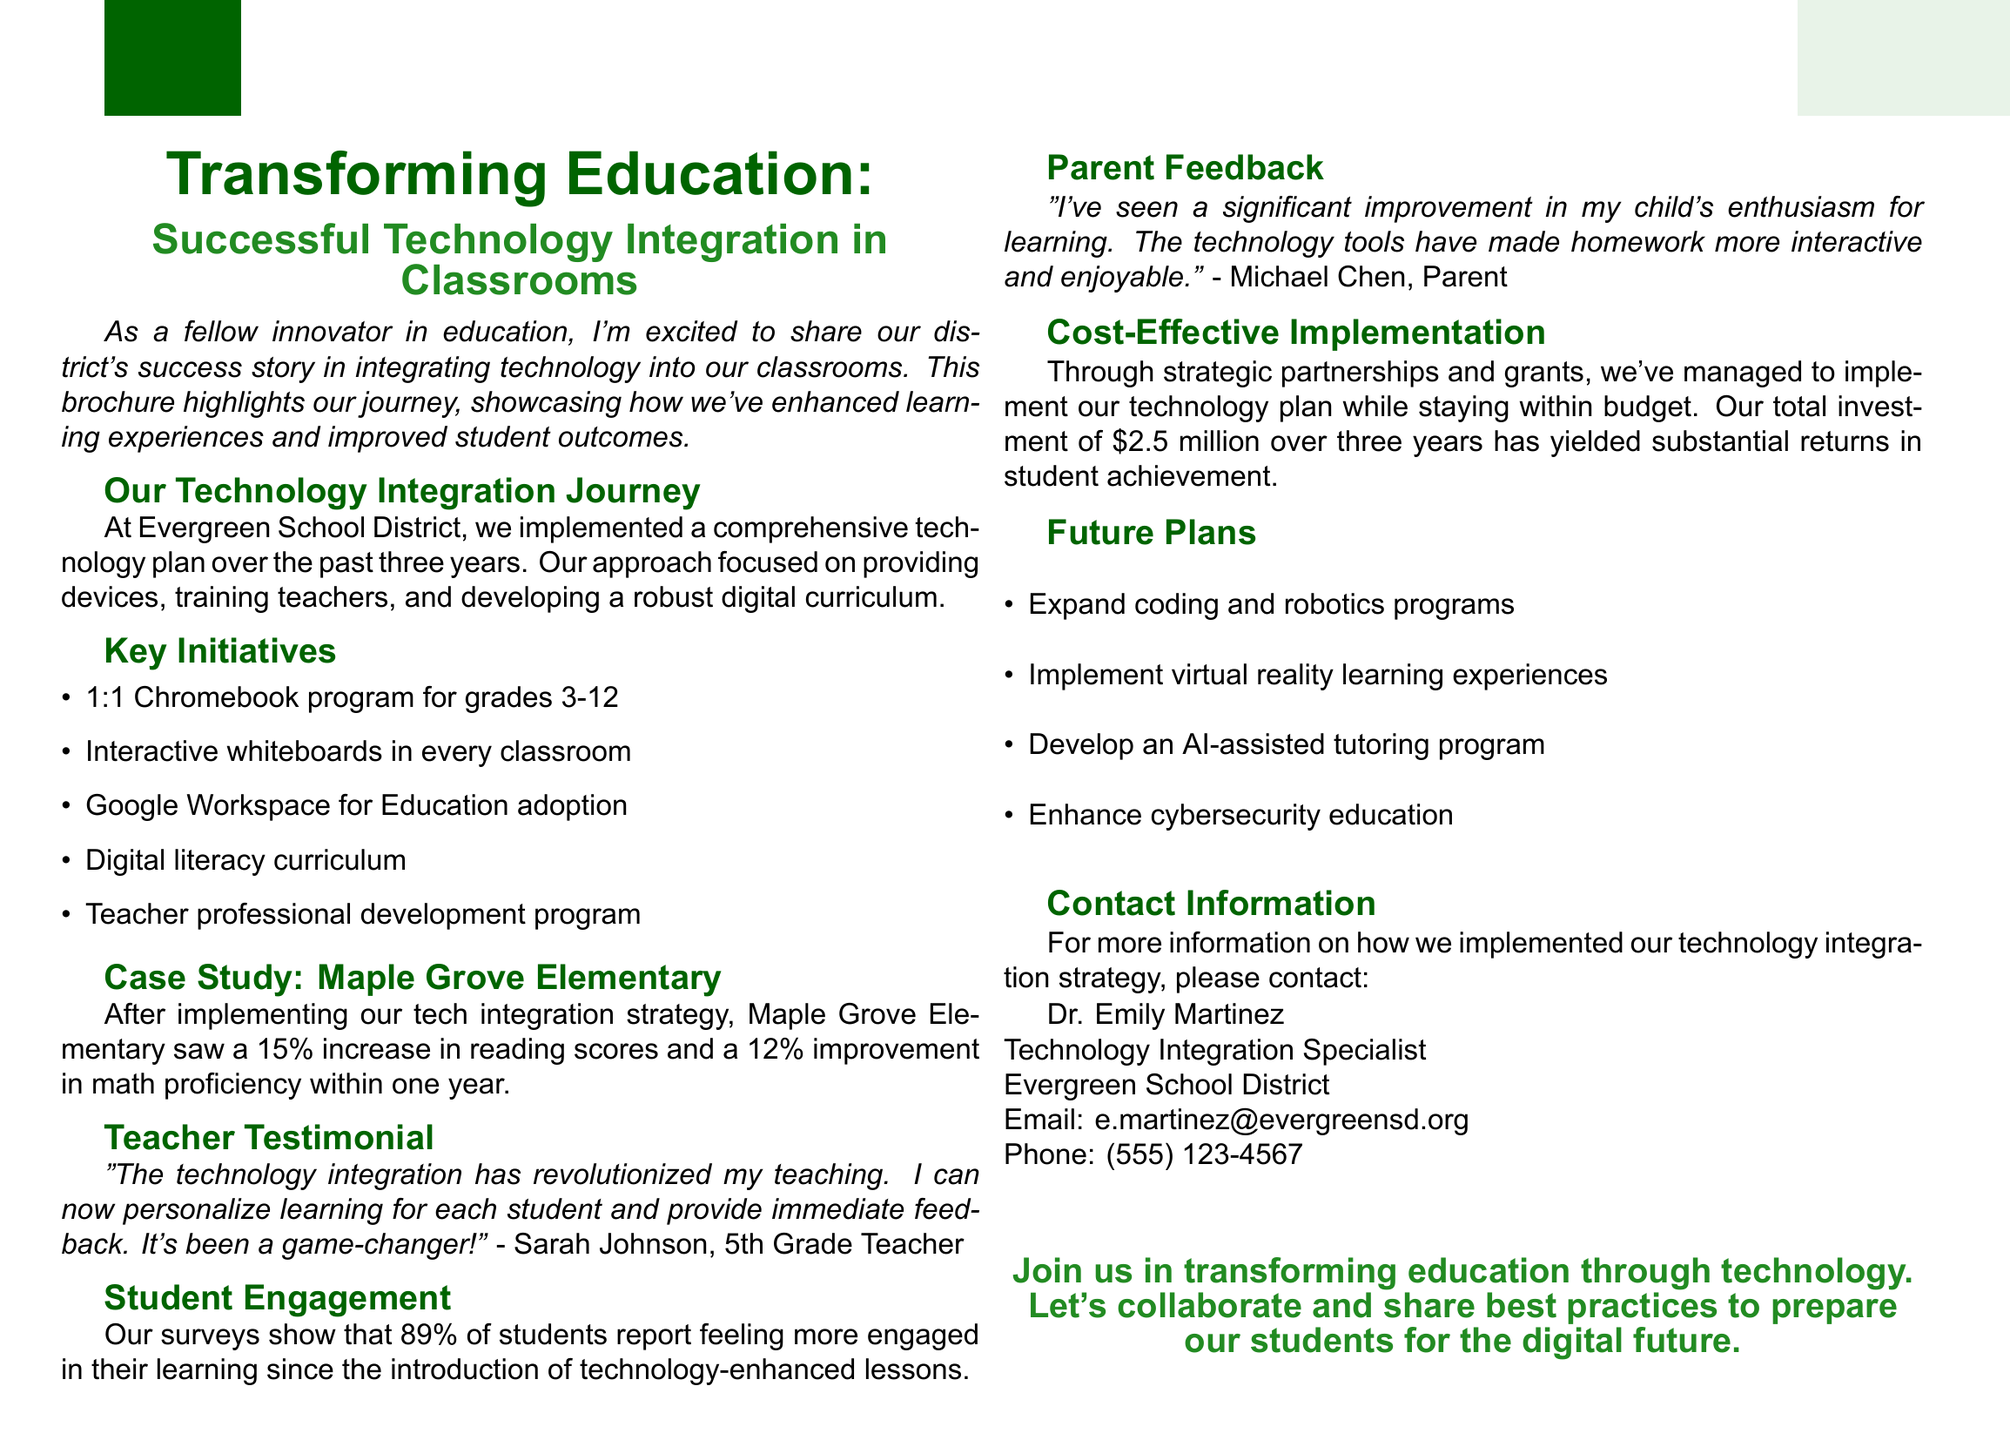What is the brochure title? The brochure title is stated at the top, highlighting the focus of the document.
Answer: Transforming Education: Successful Technology Integration in Classrooms What percentage increase in reading scores was seen at Maple Grove Elementary? This information is included in the case study section of the brochure.
Answer: 15% Who is the author of the teacher testimonial? The testimonial provided is attributed to a specific teacher, which is noted in the document.
Answer: Sarah Johnson What was the total investment made in the technology integration plan? This financial detail is shared in the cost-effective implementation section of the brochure.
Answer: $2.5 million What percentage of students feel more engaged in their learning? This statistic is mentioned in the student engagement section, reflecting student sentiment.
Answer: 89% What future plan involves AI technology? Future plans listed include several initiatives, one of which specifically refers to AI.
Answer: Develop an AI-assisted tutoring program What interactive technology was implemented in every classroom? The key initiatives section lists specific technologies adopted for classroom use.
Answer: Interactive whiteboards What is the main contact's email address? Contact information is provided at the end of the brochure, including the main contact's email.
Answer: e.martinez@evergreensd.org 